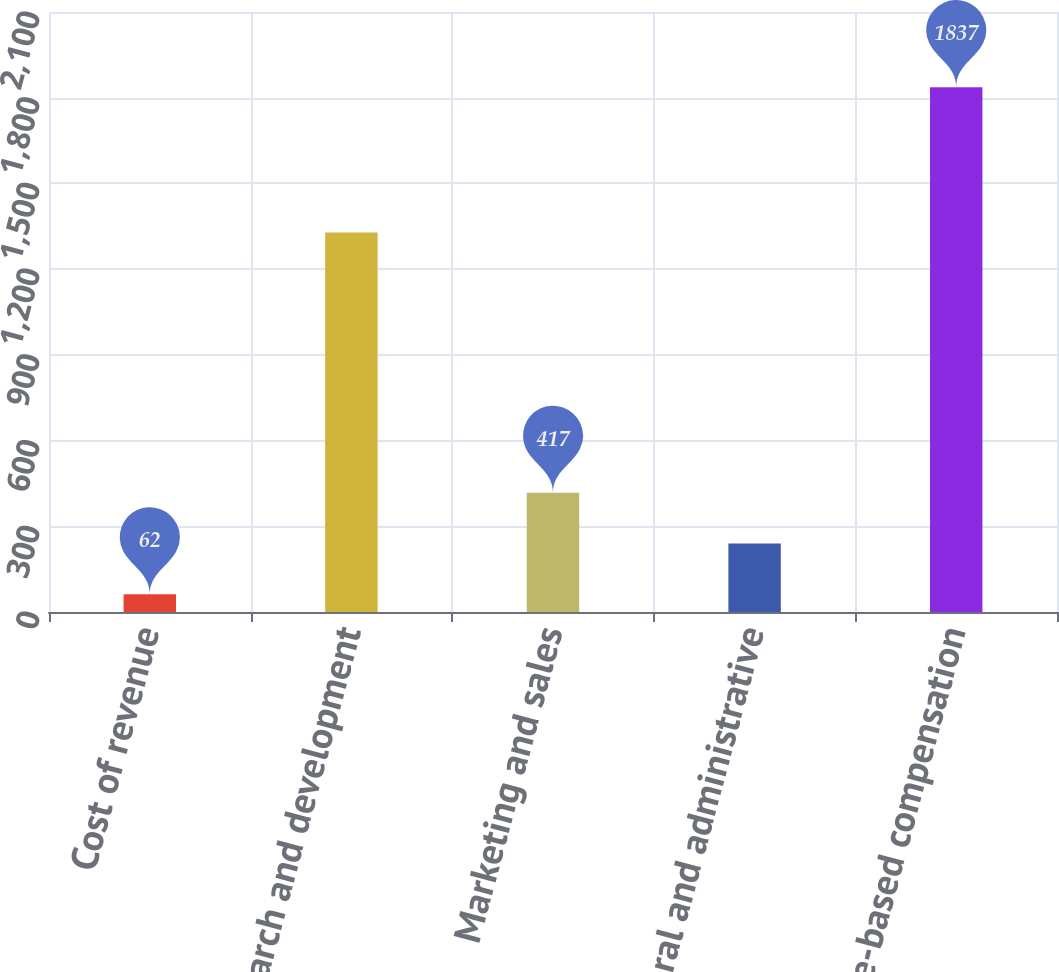<chart> <loc_0><loc_0><loc_500><loc_500><bar_chart><fcel>Cost of revenue<fcel>Research and development<fcel>Marketing and sales<fcel>General and administrative<fcel>Total share-based compensation<nl><fcel>62<fcel>1328<fcel>417<fcel>239.5<fcel>1837<nl></chart> 